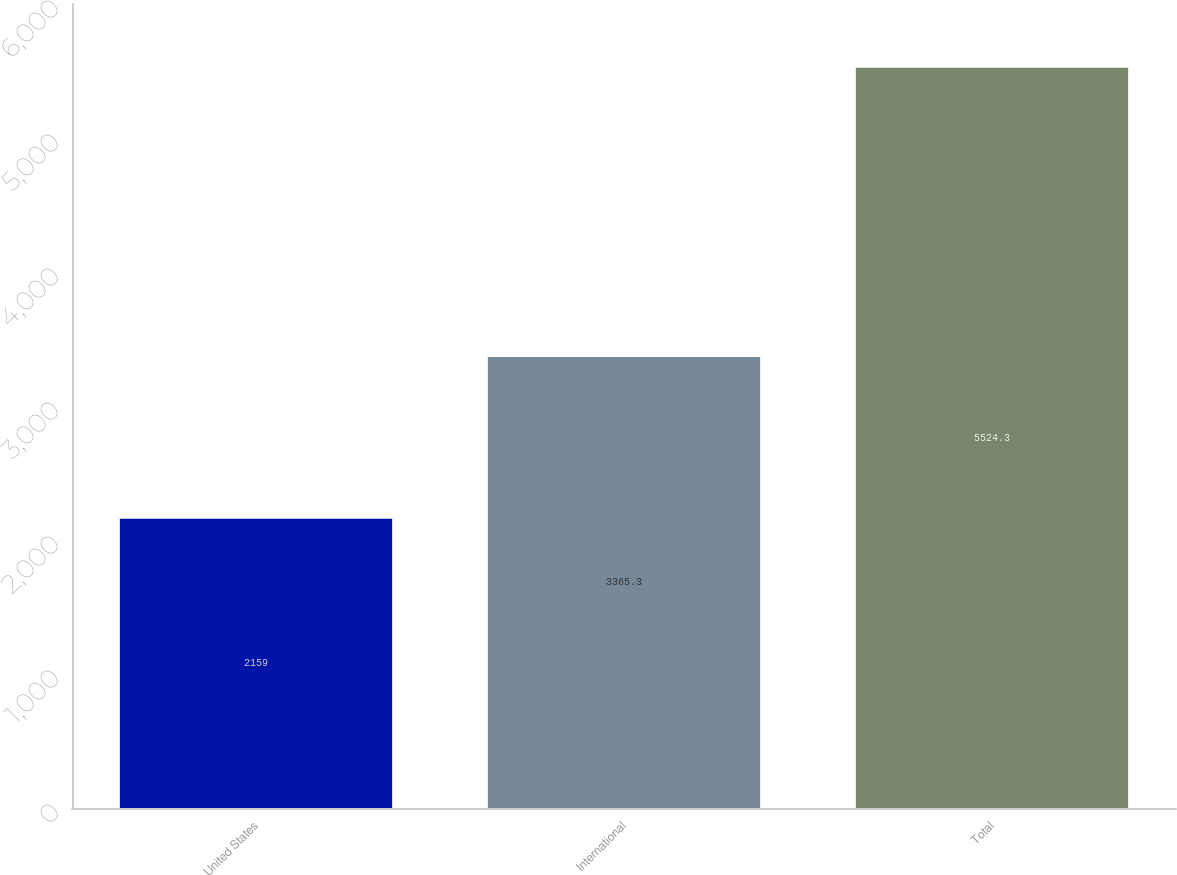Convert chart. <chart><loc_0><loc_0><loc_500><loc_500><bar_chart><fcel>United States<fcel>International<fcel>Total<nl><fcel>2159<fcel>3365.3<fcel>5524.3<nl></chart> 